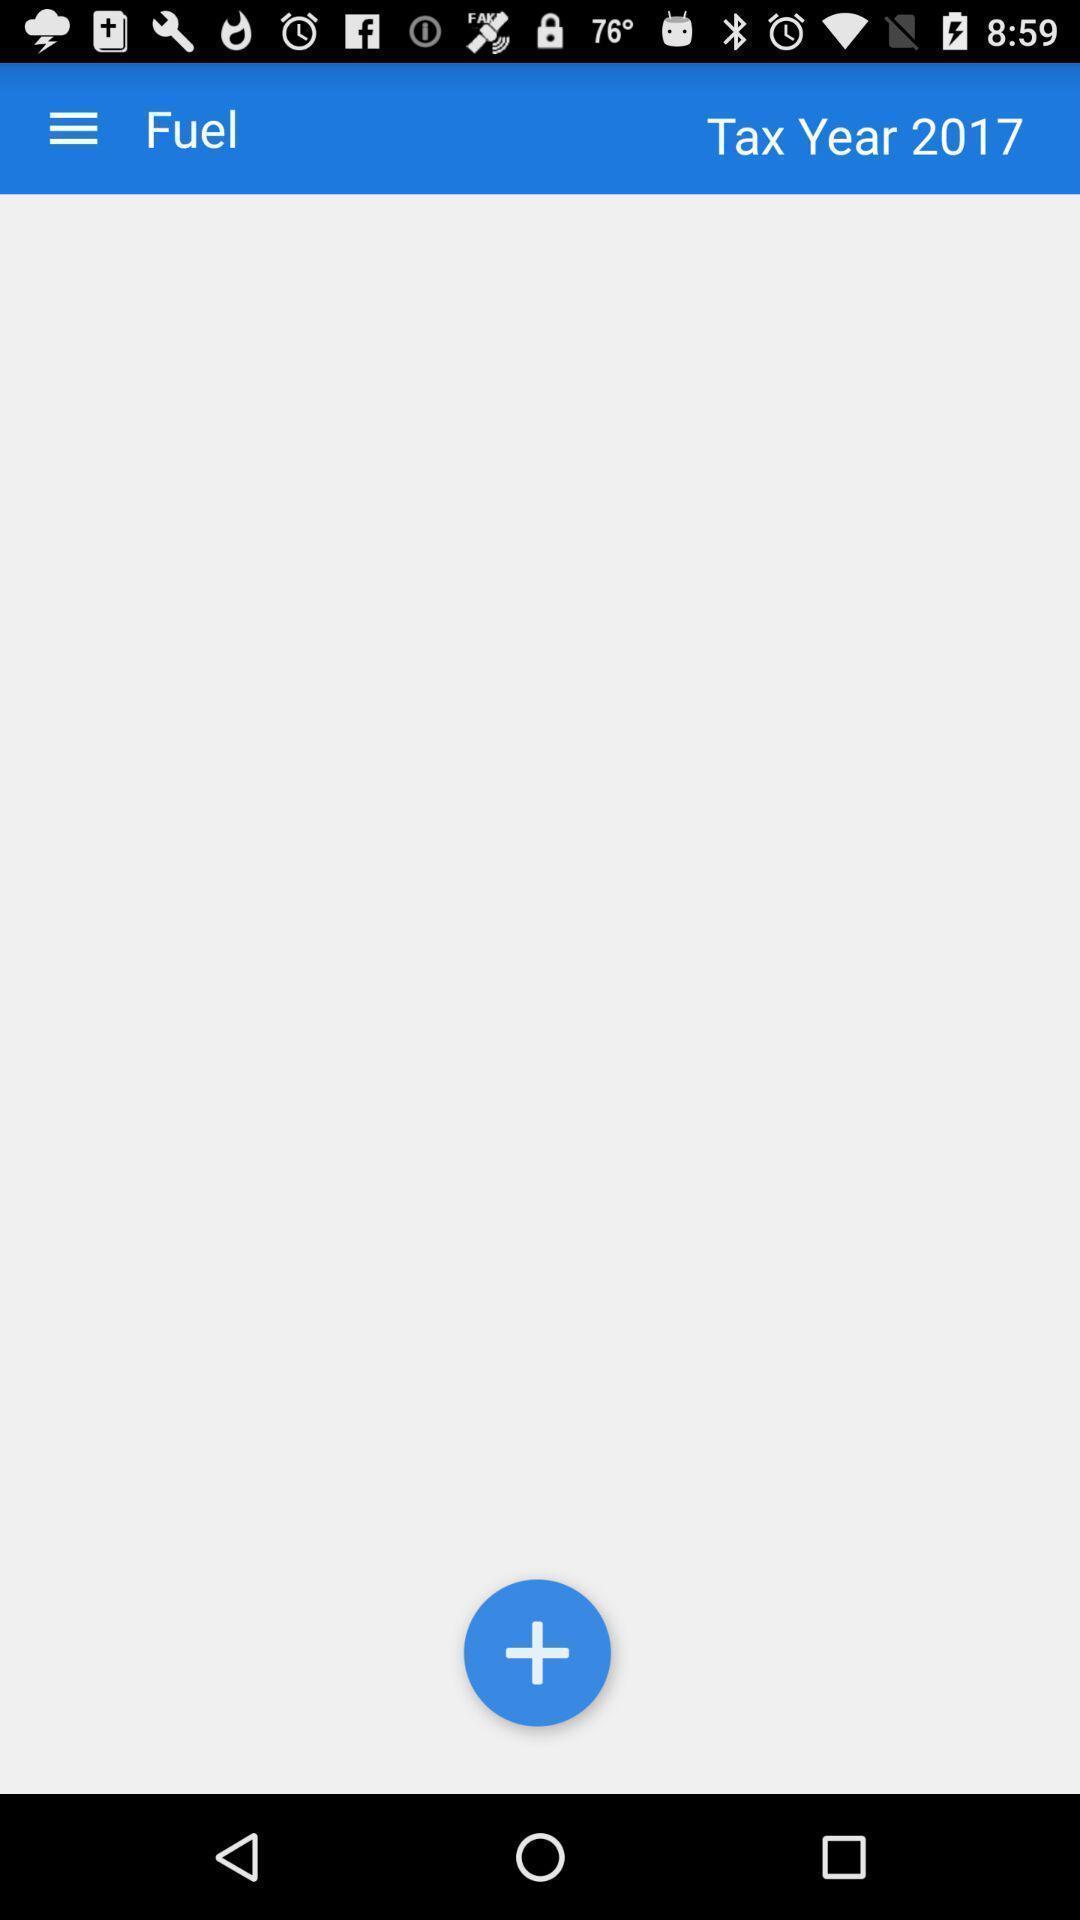Explain the elements present in this screenshot. Page displaying to add fuel details in app. 